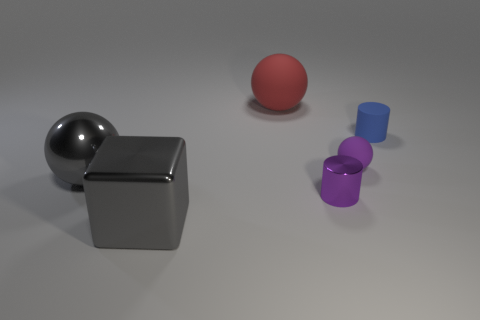What size is the shiny ball that is the same color as the metal cube?
Offer a very short reply. Large. Do the tiny purple thing that is left of the small purple matte thing and the small blue thing have the same shape?
Provide a short and direct response. Yes. There is a shiny cylinder that is the same size as the blue rubber object; what color is it?
Provide a short and direct response. Purple. There is a rubber object that is the same color as the metallic cylinder; what shape is it?
Give a very brief answer. Sphere. Are there any cubes that have the same material as the purple cylinder?
Provide a succinct answer. Yes. Is the shape of the blue thing the same as the tiny metallic object?
Ensure brevity in your answer.  Yes. Is the size of the metallic ball the same as the red object?
Your answer should be compact. Yes. There is a small cylinder that is in front of the large sphere that is in front of the big red matte sphere; is there a gray metal thing behind it?
Make the answer very short. Yes. How big is the gray metal block?
Make the answer very short. Large. What number of metal spheres have the same size as the purple metal cylinder?
Your answer should be very brief. 0. 